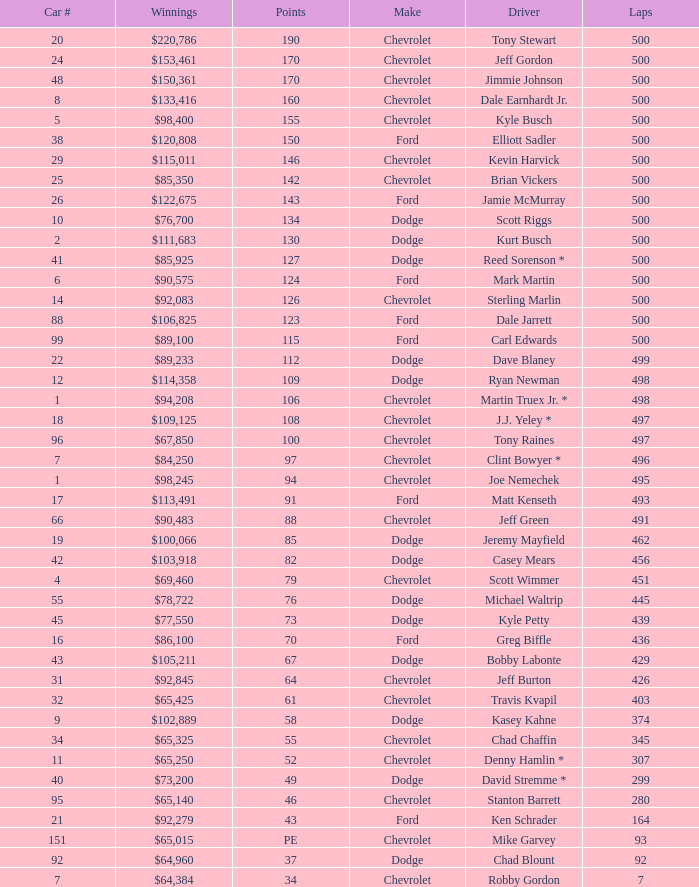What is the average car number of all the drivers who have won $111,683? 2.0. 